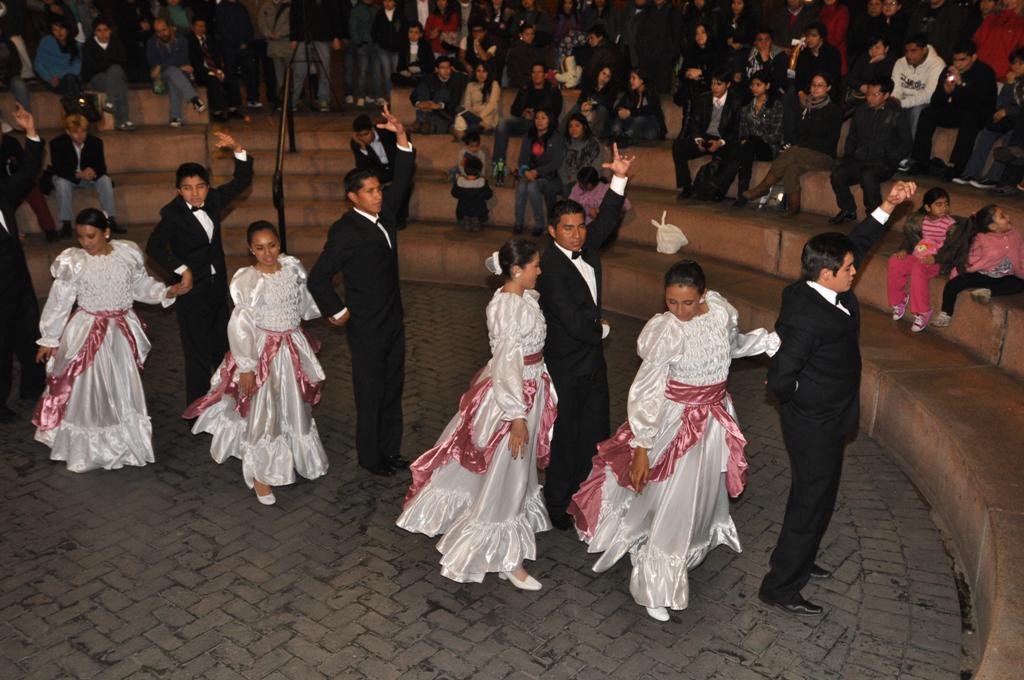What are the people in the center of the picture doing? The people in the center of the picture are dancing. What can be seen at the top of the image? There is a staircase at the top of the image. Who is sitting on the staircase? There are people sitting on the staircase, including kids. What type of power unit is visible on the staircase in the image? There is no power unit visible on the staircase in the image. What kind of stem can be seen growing from the kids' heads in the image? There are no stems growing from the kids' heads in the image. 